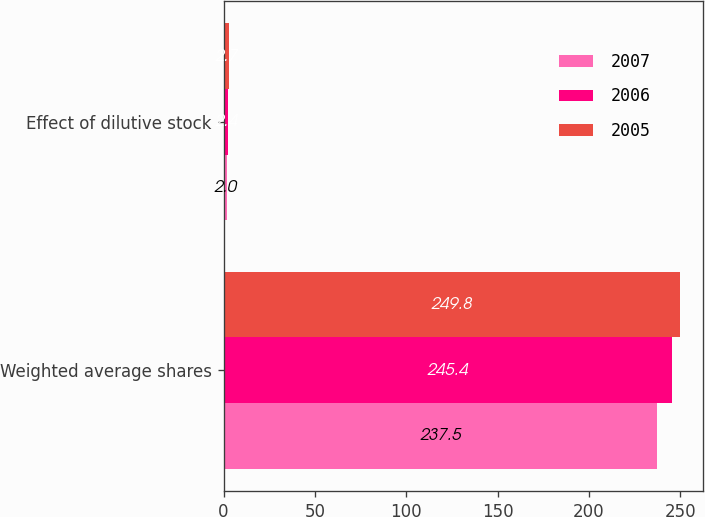<chart> <loc_0><loc_0><loc_500><loc_500><stacked_bar_chart><ecel><fcel>Weighted average shares<fcel>Effect of dilutive stock<nl><fcel>2007<fcel>237.5<fcel>2<nl><fcel>2006<fcel>245.4<fcel>2.4<nl><fcel>2005<fcel>249.8<fcel>2.7<nl></chart> 